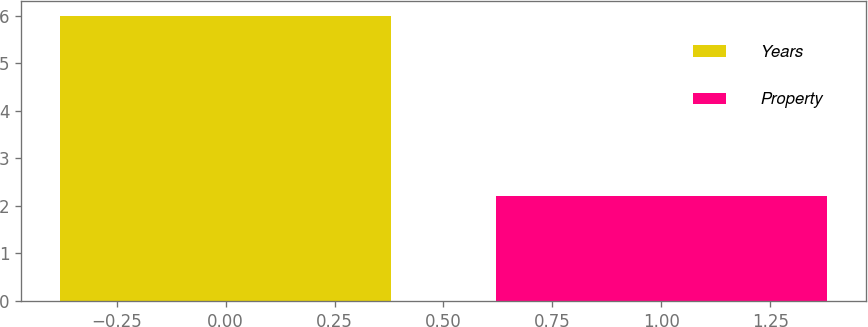<chart> <loc_0><loc_0><loc_500><loc_500><bar_chart><fcel>Years<fcel>Property<nl><fcel>6<fcel>2.2<nl></chart> 